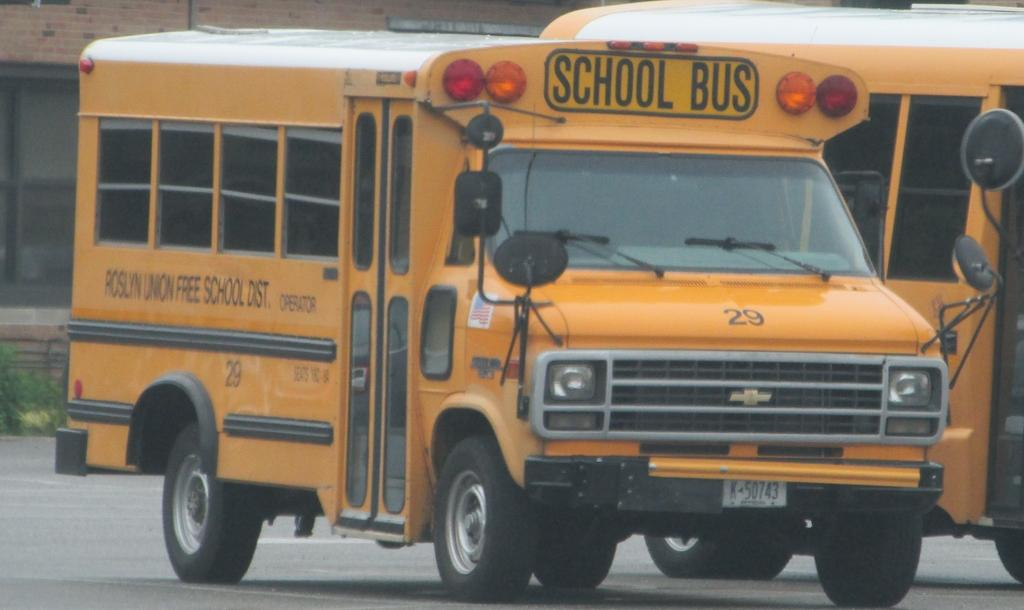<image>
Present a compact description of the photo's key features. a school bus that is on the road in daytime 